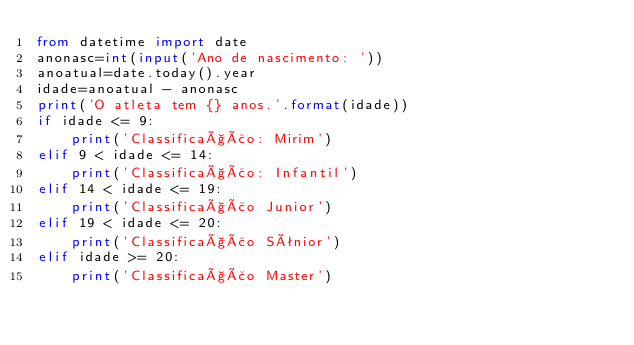<code> <loc_0><loc_0><loc_500><loc_500><_Python_>from datetime import date
anonasc=int(input('Ano de nascimento: '))
anoatual=date.today().year
idade=anoatual - anonasc
print('O atleta tem {} anos.'.format(idade))
if idade <= 9:
    print('Classificação: Mirim')
elif 9 < idade <= 14:
    print('Classificação: Infantil')
elif 14 < idade <= 19:
    print('Classificação Junior')
elif 19 < idade <= 20:
    print('Classificação Sênior')
elif idade >= 20:
    print('Classificação Master')
</code> 